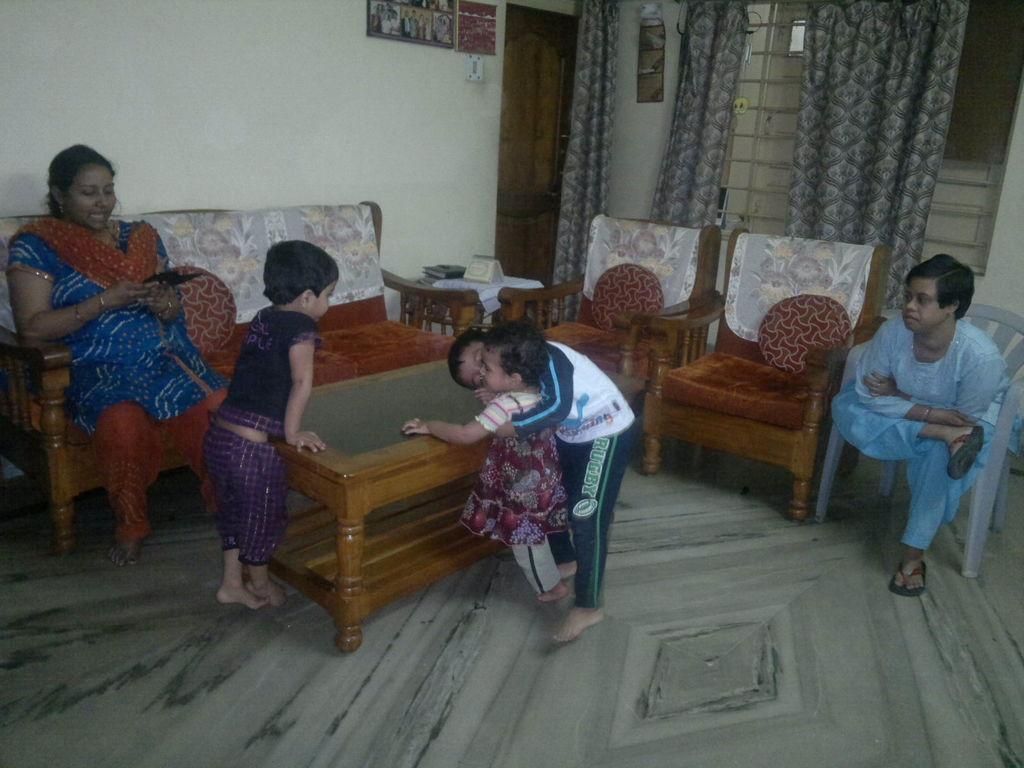Could you give a brief overview of what you see in this image? In the left middle of the image, there is a woman sitting on the sofa. In the middle of the image, there are three kids playing on the table. In the right bottom of the image, there is a man sitting on the chair. In the right top of the image, there is a window on which curtain is there. In the left top of the image, there is a wall which is white in color and a photo-frame is there. This image is taken inside a house. 